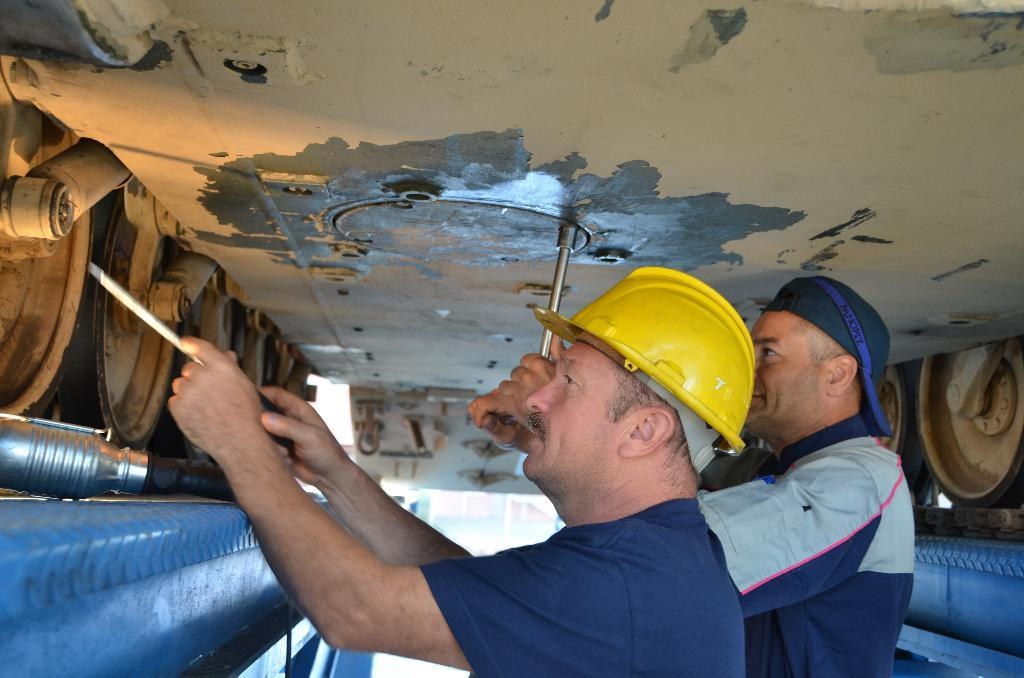How many people are in the image? There are two people in the image. What are the people wearing on their upper bodies? Both people are wearing blue t-shirts. What are the people wearing on their heads? Both people are wearing yellow helmets. What can be seen behind the people in the image? The people are standing in front of a train. What are the people doing in the image? The people are repairing the train wheels. Can you tell me how many times the person on the left has made an error while repairing the train wheels? There is no information about errors or the number of errors made in the image. What type of breath is visible coming from the person on the right? There is no visible breath in the image, as it is not cold enough or the people are not exerting themselves enough to produce visible breath. 